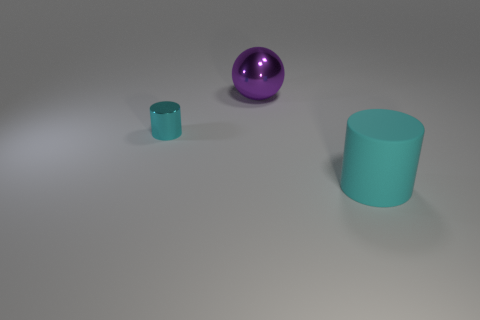The object that is behind the rubber object and right of the small cyan shiny cylinder is what color?
Your answer should be very brief. Purple. There is a object that is right of the large object behind the thing on the right side of the purple metallic thing; what is its material?
Ensure brevity in your answer.  Rubber. What is the material of the big cyan object?
Ensure brevity in your answer.  Rubber. There is a cyan metallic thing that is the same shape as the large cyan rubber thing; what size is it?
Provide a succinct answer. Small. Is the color of the metallic cylinder the same as the large cylinder?
Provide a short and direct response. Yes. How many other things are there of the same material as the large purple object?
Keep it short and to the point. 1. Are there the same number of small cylinders to the right of the big metal ball and metal balls?
Make the answer very short. No. There is a cyan cylinder that is in front of the cyan metal thing; is it the same size as the big purple thing?
Your response must be concise. Yes. How many large cyan cylinders are to the left of the small metal cylinder?
Your answer should be compact. 0. There is a object that is both in front of the big metallic ball and to the right of the cyan shiny cylinder; what is its material?
Ensure brevity in your answer.  Rubber. 